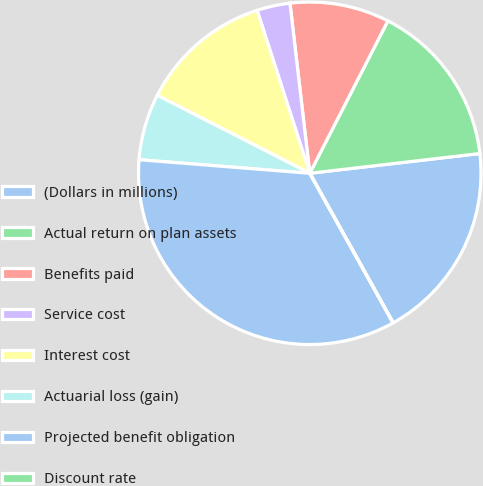Convert chart. <chart><loc_0><loc_0><loc_500><loc_500><pie_chart><fcel>(Dollars in millions)<fcel>Actual return on plan assets<fcel>Benefits paid<fcel>Service cost<fcel>Interest cost<fcel>Actuarial loss (gain)<fcel>Projected benefit obligation<fcel>Discount rate<nl><fcel>18.74%<fcel>15.62%<fcel>9.38%<fcel>3.13%<fcel>12.5%<fcel>6.26%<fcel>34.35%<fcel>0.01%<nl></chart> 